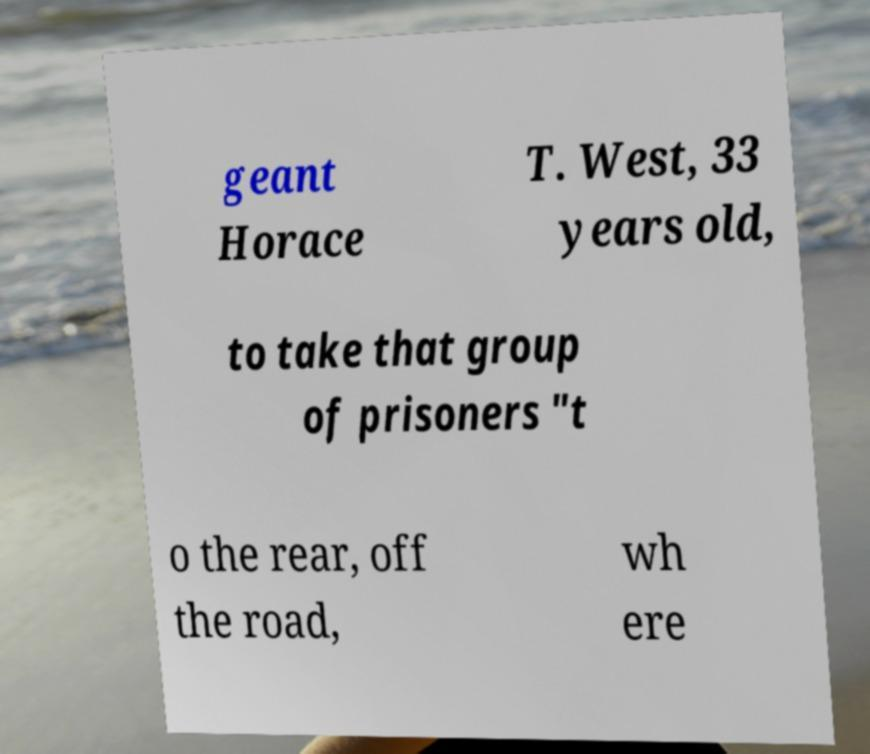Could you assist in decoding the text presented in this image and type it out clearly? geant Horace T. West, 33 years old, to take that group of prisoners "t o the rear, off the road, wh ere 